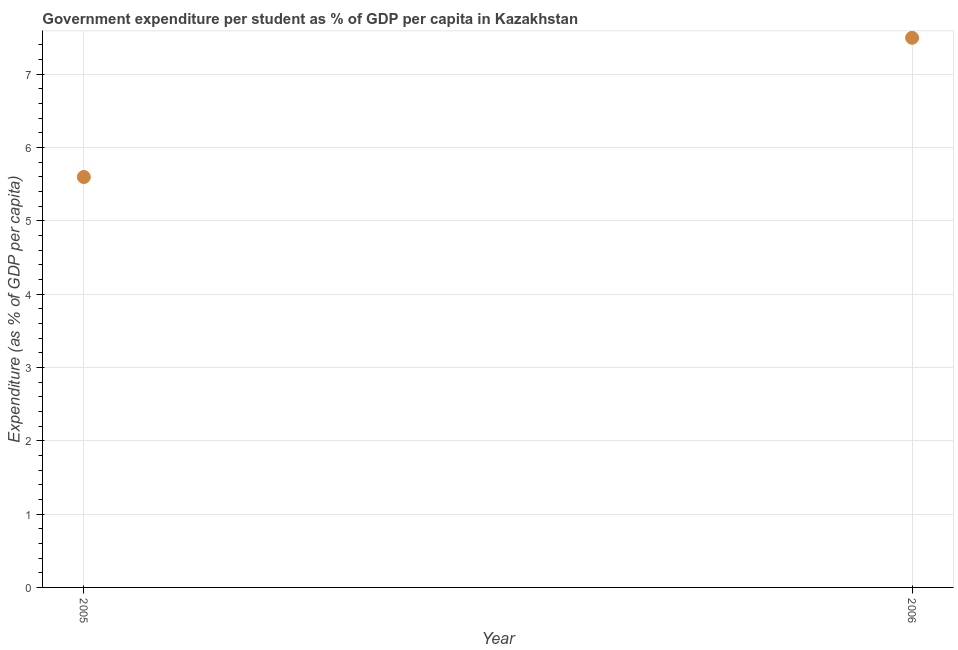What is the government expenditure per student in 2006?
Your response must be concise. 7.5. Across all years, what is the maximum government expenditure per student?
Offer a very short reply. 7.5. Across all years, what is the minimum government expenditure per student?
Keep it short and to the point. 5.6. In which year was the government expenditure per student minimum?
Keep it short and to the point. 2005. What is the sum of the government expenditure per student?
Offer a very short reply. 13.09. What is the difference between the government expenditure per student in 2005 and 2006?
Ensure brevity in your answer.  -1.9. What is the average government expenditure per student per year?
Offer a terse response. 6.55. What is the median government expenditure per student?
Ensure brevity in your answer.  6.55. What is the ratio of the government expenditure per student in 2005 to that in 2006?
Your answer should be very brief. 0.75. Is the government expenditure per student in 2005 less than that in 2006?
Offer a very short reply. Yes. In how many years, is the government expenditure per student greater than the average government expenditure per student taken over all years?
Keep it short and to the point. 1. Does the government expenditure per student monotonically increase over the years?
Provide a short and direct response. Yes. How many dotlines are there?
Offer a very short reply. 1. What is the difference between two consecutive major ticks on the Y-axis?
Ensure brevity in your answer.  1. Does the graph contain any zero values?
Your answer should be compact. No. Does the graph contain grids?
Provide a succinct answer. Yes. What is the title of the graph?
Your response must be concise. Government expenditure per student as % of GDP per capita in Kazakhstan. What is the label or title of the Y-axis?
Your answer should be very brief. Expenditure (as % of GDP per capita). What is the Expenditure (as % of GDP per capita) in 2005?
Offer a very short reply. 5.6. What is the Expenditure (as % of GDP per capita) in 2006?
Your answer should be compact. 7.5. What is the difference between the Expenditure (as % of GDP per capita) in 2005 and 2006?
Your answer should be very brief. -1.9. What is the ratio of the Expenditure (as % of GDP per capita) in 2005 to that in 2006?
Provide a succinct answer. 0.75. 